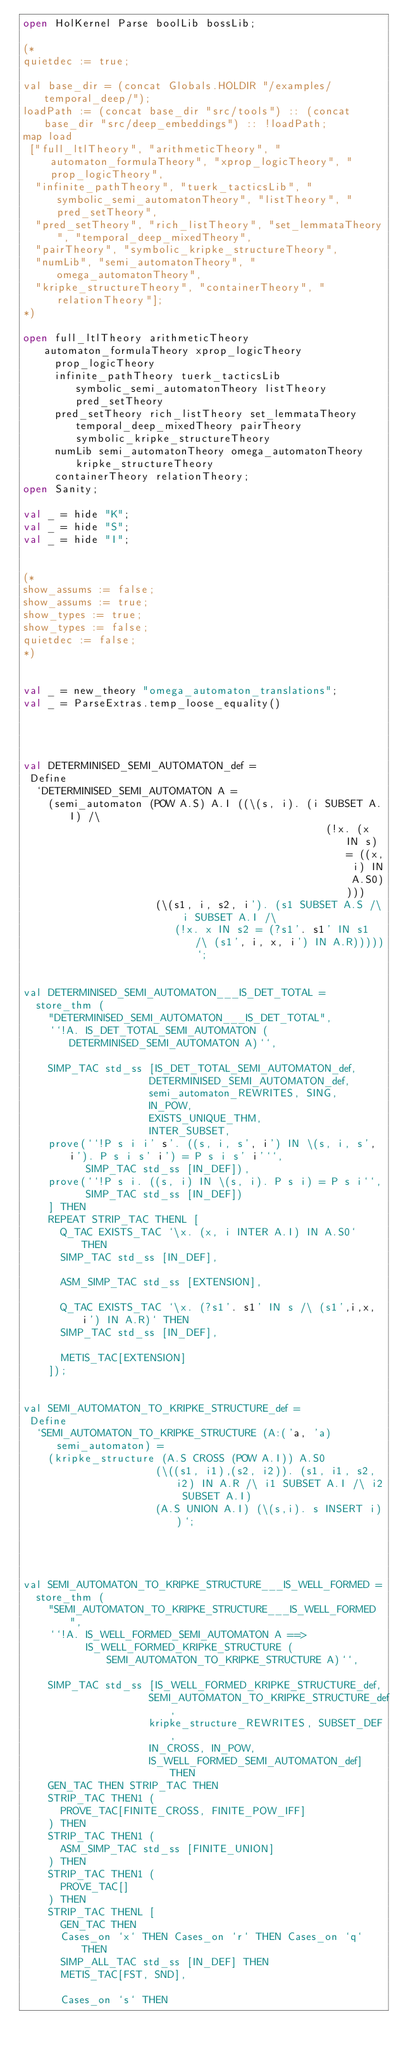Convert code to text. <code><loc_0><loc_0><loc_500><loc_500><_SML_>open HolKernel Parse boolLib bossLib;

(*
quietdec := true;

val base_dir = (concat Globals.HOLDIR "/examples/temporal_deep/");
loadPath := (concat base_dir "src/tools") :: (concat base_dir "src/deep_embeddings") :: !loadPath;
map load
 ["full_ltlTheory", "arithmeticTheory", "automaton_formulaTheory", "xprop_logicTheory", "prop_logicTheory",
  "infinite_pathTheory", "tuerk_tacticsLib", "symbolic_semi_automatonTheory", "listTheory", "pred_setTheory",
  "pred_setTheory", "rich_listTheory", "set_lemmataTheory", "temporal_deep_mixedTheory",
  "pairTheory", "symbolic_kripke_structureTheory",
  "numLib", "semi_automatonTheory", "omega_automatonTheory",
  "kripke_structureTheory", "containerTheory", "relationTheory"];
*)

open full_ltlTheory arithmeticTheory automaton_formulaTheory xprop_logicTheory
     prop_logicTheory
     infinite_pathTheory tuerk_tacticsLib symbolic_semi_automatonTheory listTheory pred_setTheory
     pred_setTheory rich_listTheory set_lemmataTheory temporal_deep_mixedTheory pairTheory symbolic_kripke_structureTheory
     numLib semi_automatonTheory omega_automatonTheory kripke_structureTheory
     containerTheory relationTheory;
open Sanity;

val _ = hide "K";
val _ = hide "S";
val _ = hide "I";


(*
show_assums := false;
show_assums := true;
show_types := true;
show_types := false;
quietdec := false;
*)


val _ = new_theory "omega_automaton_translations";
val _ = ParseExtras.temp_loose_equality()




val DETERMINISED_SEMI_AUTOMATON_def =
 Define
  `DETERMINISED_SEMI_AUTOMATON A =
    (semi_automaton (POW A.S) A.I ((\(s, i). (i SUBSET A.I) /\
                                                (!x. (x IN s) = ((x, i) IN A.S0))))
                     (\(s1, i, s2, i'). (s1 SUBSET A.S /\ i SUBSET A.I /\
                        (!x. x IN s2 = (?s1'. s1' IN s1 /\ (s1', i, x, i') IN A.R)))))`;


val DETERMINISED_SEMI_AUTOMATON___IS_DET_TOTAL =
  store_thm (
    "DETERMINISED_SEMI_AUTOMATON___IS_DET_TOTAL",
    ``!A. IS_DET_TOTAL_SEMI_AUTOMATON (DETERMINISED_SEMI_AUTOMATON A)``,

    SIMP_TAC std_ss [IS_DET_TOTAL_SEMI_AUTOMATON_def,
                    DETERMINISED_SEMI_AUTOMATON_def,
                    semi_automaton_REWRITES, SING,
                    IN_POW,
                    EXISTS_UNIQUE_THM,
                    INTER_SUBSET,
    prove(``!P s i i' s'. ((s, i, s', i') IN \(s, i, s', i'). P s i s' i') = P s i s' i'``,
          SIMP_TAC std_ss [IN_DEF]),
    prove(``!P s i. ((s, i) IN \(s, i). P s i) = P s i``,
          SIMP_TAC std_ss [IN_DEF])
    ] THEN
    REPEAT STRIP_TAC THENL [
      Q_TAC EXISTS_TAC `\x. (x, i INTER A.I) IN A.S0` THEN
      SIMP_TAC std_ss [IN_DEF],

      ASM_SIMP_TAC std_ss [EXTENSION],

      Q_TAC EXISTS_TAC `\x. (?s1'. s1' IN s /\ (s1',i,x, i') IN A.R)` THEN
      SIMP_TAC std_ss [IN_DEF],

      METIS_TAC[EXTENSION]
    ]);


val SEMI_AUTOMATON_TO_KRIPKE_STRUCTURE_def =
 Define
  `SEMI_AUTOMATON_TO_KRIPKE_STRUCTURE (A:('a, 'a) semi_automaton) =
    (kripke_structure (A.S CROSS (POW A.I)) A.S0
                     (\((s1, i1),(s2, i2)). (s1, i1, s2, i2) IN A.R /\ i1 SUBSET A.I /\ i2 SUBSET A.I)
                     (A.S UNION A.I) (\(s,i). s INSERT i))`;




val SEMI_AUTOMATON_TO_KRIPKE_STRUCTURE___IS_WELL_FORMED =
  store_thm (
    "SEMI_AUTOMATON_TO_KRIPKE_STRUCTURE___IS_WELL_FORMED",
    ``!A. IS_WELL_FORMED_SEMI_AUTOMATON A ==>
          IS_WELL_FORMED_KRIPKE_STRUCTURE (SEMI_AUTOMATON_TO_KRIPKE_STRUCTURE A)``,

    SIMP_TAC std_ss [IS_WELL_FORMED_KRIPKE_STRUCTURE_def,
                    SEMI_AUTOMATON_TO_KRIPKE_STRUCTURE_def,
                    kripke_structure_REWRITES, SUBSET_DEF,
                    IN_CROSS, IN_POW,
                    IS_WELL_FORMED_SEMI_AUTOMATON_def] THEN
    GEN_TAC THEN STRIP_TAC THEN
    STRIP_TAC THEN1 (
      PROVE_TAC[FINITE_CROSS, FINITE_POW_IFF]
    ) THEN
    STRIP_TAC THEN1 (
      ASM_SIMP_TAC std_ss [FINITE_UNION]
    ) THEN
    STRIP_TAC THEN1 (
      PROVE_TAC[]
    ) THEN
    STRIP_TAC THENL [
      GEN_TAC THEN
      Cases_on `x` THEN Cases_on `r` THEN Cases_on `q` THEN
      SIMP_ALL_TAC std_ss [IN_DEF] THEN
      METIS_TAC[FST, SND],

      Cases_on `s` THEN</code> 